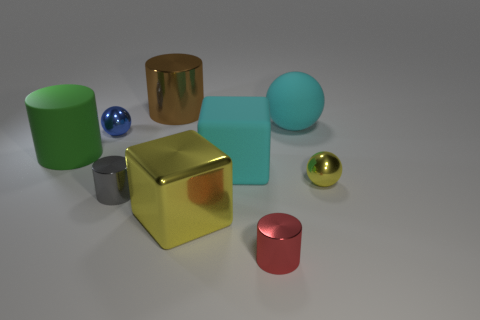There is a cylinder that is the same material as the cyan sphere; what is its color?
Ensure brevity in your answer.  Green. How many green cylinders are the same material as the large cyan sphere?
Provide a short and direct response. 1. Do the brown cylinder and the big cube that is in front of the yellow metal ball have the same material?
Ensure brevity in your answer.  Yes. How many things are small metallic objects that are to the left of the big brown metallic thing or yellow things?
Ensure brevity in your answer.  4. There is a yellow thing that is in front of the small metallic ball in front of the large cyan object that is on the left side of the large ball; what size is it?
Offer a terse response. Large. There is a small ball that is the same color as the shiny cube; what is its material?
Keep it short and to the point. Metal. Is there any other thing that is the same shape as the large green object?
Your answer should be very brief. Yes. There is a yellow thing to the left of the metallic ball in front of the small blue shiny thing; what size is it?
Your answer should be compact. Large. What number of small objects are green shiny blocks or yellow objects?
Keep it short and to the point. 1. Is the number of red cylinders less than the number of red matte things?
Make the answer very short. No. 